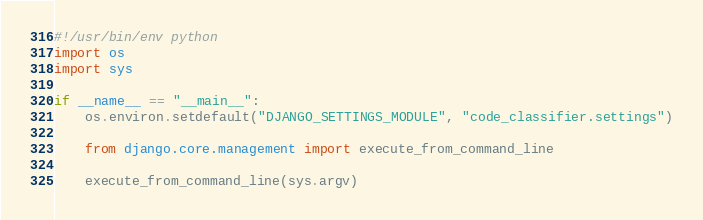Convert code to text. <code><loc_0><loc_0><loc_500><loc_500><_Python_>#!/usr/bin/env python
import os
import sys

if __name__ == "__main__":
    os.environ.setdefault("DJANGO_SETTINGS_MODULE", "code_classifier.settings")

    from django.core.management import execute_from_command_line

    execute_from_command_line(sys.argv)
</code> 